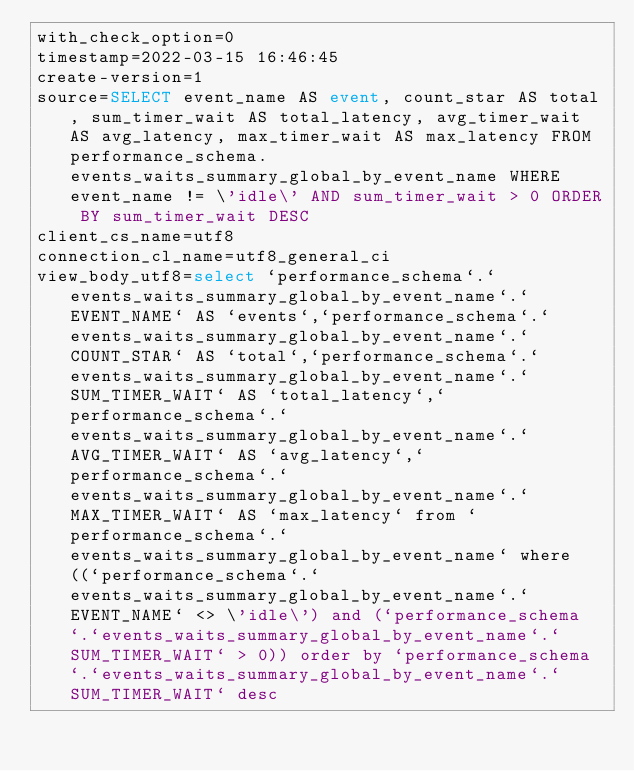<code> <loc_0><loc_0><loc_500><loc_500><_VisualBasic_>with_check_option=0
timestamp=2022-03-15 16:46:45
create-version=1
source=SELECT event_name AS event, count_star AS total, sum_timer_wait AS total_latency, avg_timer_wait AS avg_latency, max_timer_wait AS max_latency FROM performance_schema.events_waits_summary_global_by_event_name WHERE event_name != \'idle\' AND sum_timer_wait > 0 ORDER BY sum_timer_wait DESC
client_cs_name=utf8
connection_cl_name=utf8_general_ci
view_body_utf8=select `performance_schema`.`events_waits_summary_global_by_event_name`.`EVENT_NAME` AS `events`,`performance_schema`.`events_waits_summary_global_by_event_name`.`COUNT_STAR` AS `total`,`performance_schema`.`events_waits_summary_global_by_event_name`.`SUM_TIMER_WAIT` AS `total_latency`,`performance_schema`.`events_waits_summary_global_by_event_name`.`AVG_TIMER_WAIT` AS `avg_latency`,`performance_schema`.`events_waits_summary_global_by_event_name`.`MAX_TIMER_WAIT` AS `max_latency` from `performance_schema`.`events_waits_summary_global_by_event_name` where ((`performance_schema`.`events_waits_summary_global_by_event_name`.`EVENT_NAME` <> \'idle\') and (`performance_schema`.`events_waits_summary_global_by_event_name`.`SUM_TIMER_WAIT` > 0)) order by `performance_schema`.`events_waits_summary_global_by_event_name`.`SUM_TIMER_WAIT` desc
</code> 